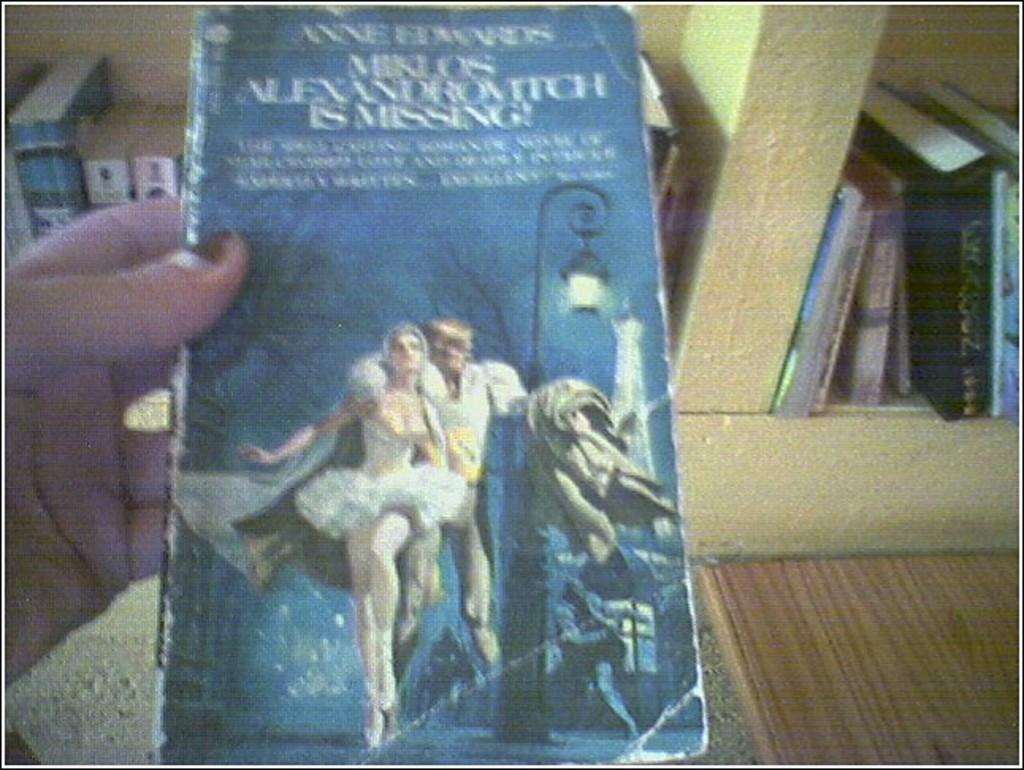Please provide a concise description of this image. In the foreground of the pictures there is a person holding a book. In the background there are books in bookshelf. On the right there is a wooden desk. 